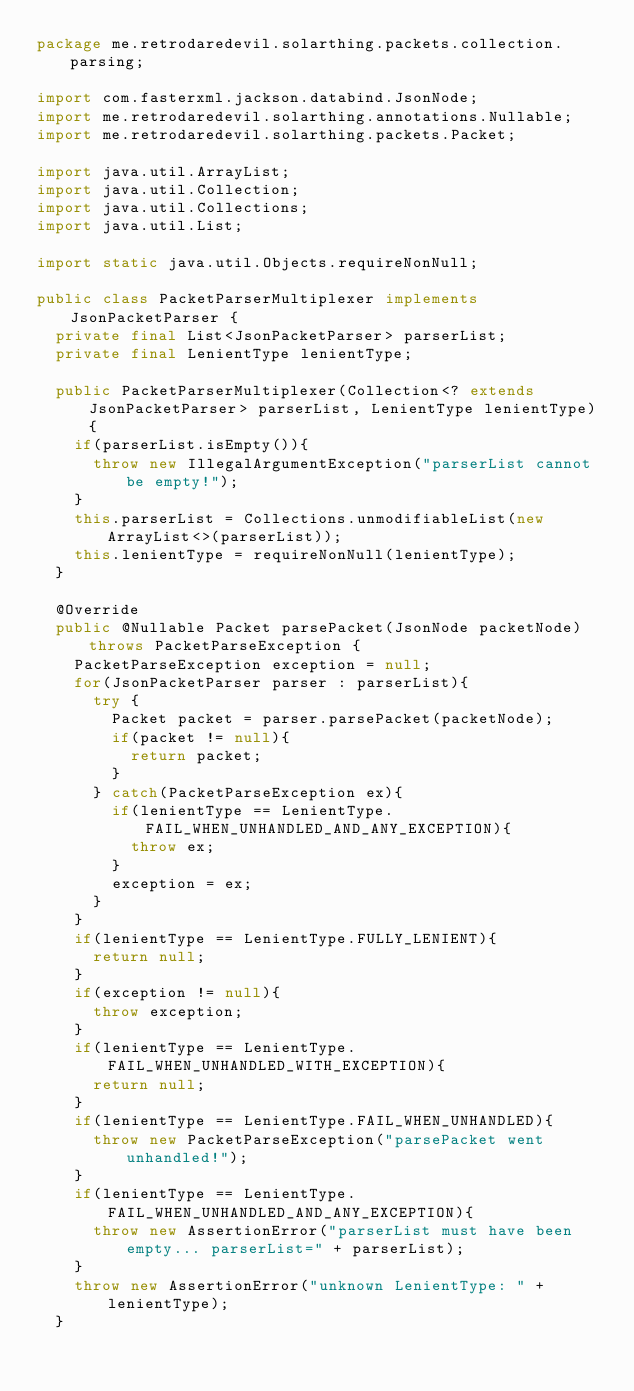<code> <loc_0><loc_0><loc_500><loc_500><_Java_>package me.retrodaredevil.solarthing.packets.collection.parsing;

import com.fasterxml.jackson.databind.JsonNode;
import me.retrodaredevil.solarthing.annotations.Nullable;
import me.retrodaredevil.solarthing.packets.Packet;

import java.util.ArrayList;
import java.util.Collection;
import java.util.Collections;
import java.util.List;

import static java.util.Objects.requireNonNull;

public class PacketParserMultiplexer implements JsonPacketParser {
	private final List<JsonPacketParser> parserList;
	private final LenientType lenientType;

	public PacketParserMultiplexer(Collection<? extends JsonPacketParser> parserList, LenientType lenientType) {
		if(parserList.isEmpty()){
			throw new IllegalArgumentException("parserList cannot be empty!");
		}
		this.parserList = Collections.unmodifiableList(new ArrayList<>(parserList));
		this.lenientType = requireNonNull(lenientType);
	}

	@Override
	public @Nullable Packet parsePacket(JsonNode packetNode) throws PacketParseException {
		PacketParseException exception = null;
		for(JsonPacketParser parser : parserList){
			try {
				Packet packet = parser.parsePacket(packetNode);
				if(packet != null){
					return packet;
				}
			} catch(PacketParseException ex){
				if(lenientType == LenientType.FAIL_WHEN_UNHANDLED_AND_ANY_EXCEPTION){
					throw ex;
				}
				exception = ex;
			}
		}
		if(lenientType == LenientType.FULLY_LENIENT){
			return null;
		}
		if(exception != null){
			throw exception;
		}
		if(lenientType == LenientType.FAIL_WHEN_UNHANDLED_WITH_EXCEPTION){
			return null;
		}
		if(lenientType == LenientType.FAIL_WHEN_UNHANDLED){
			throw new PacketParseException("parsePacket went unhandled!");
		}
		if(lenientType == LenientType.FAIL_WHEN_UNHANDLED_AND_ANY_EXCEPTION){
			throw new AssertionError("parserList must have been empty... parserList=" + parserList);
		}
		throw new AssertionError("unknown LenientType: " + lenientType);
	}</code> 